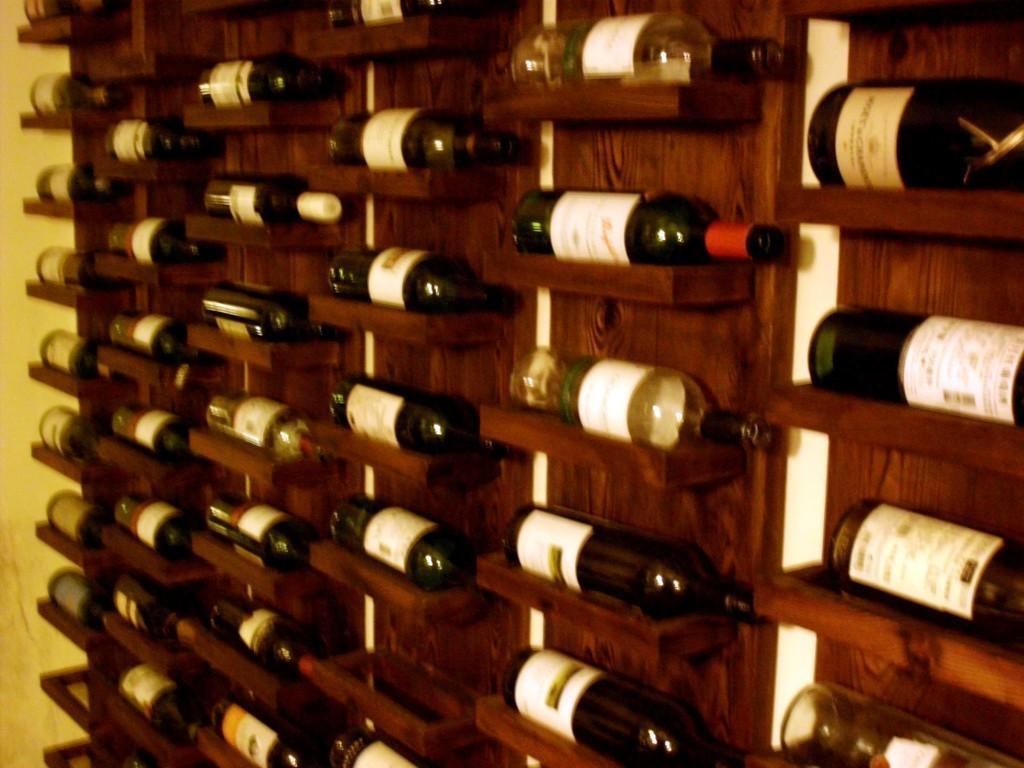What objects are arranged in the image? There are bottles arranged in a rack in the image. What can be seen on the left side of the image? There is a wall on the left side of the image. How does the daughter interact with the bottles in the image? There is no daughter present in the image, so it is not possible to answer that question. 